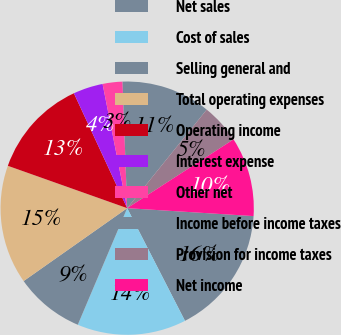Convert chart to OTSL. <chart><loc_0><loc_0><loc_500><loc_500><pie_chart><fcel>Net sales<fcel>Cost of sales<fcel>Selling general and<fcel>Total operating expenses<fcel>Operating income<fcel>Interest expense<fcel>Other net<fcel>Income before income taxes<fcel>Provision for income taxes<fcel>Net income<nl><fcel>16.46%<fcel>13.92%<fcel>8.86%<fcel>15.19%<fcel>12.66%<fcel>3.8%<fcel>2.53%<fcel>11.39%<fcel>5.06%<fcel>10.13%<nl></chart> 